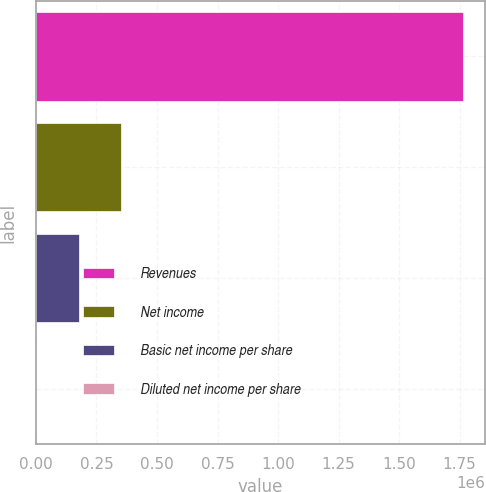Convert chart. <chart><loc_0><loc_0><loc_500><loc_500><bar_chart><fcel>Revenues<fcel>Net income<fcel>Basic net income per share<fcel>Diluted net income per share<nl><fcel>1.7654e+06<fcel>353081<fcel>176542<fcel>2.22<nl></chart> 